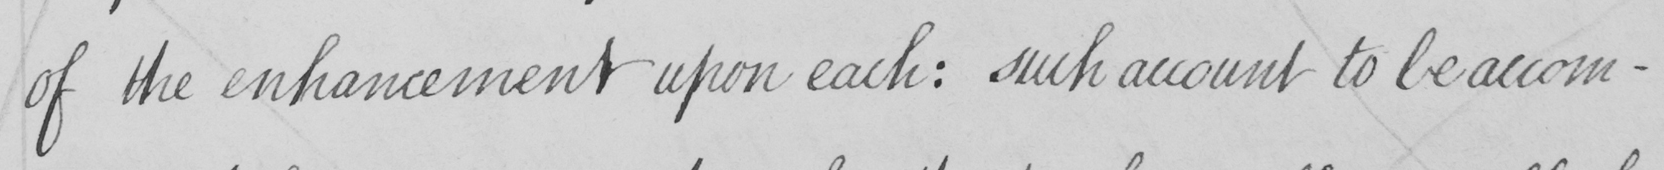Please transcribe the handwritten text in this image. of the enhancement upon each :  such account to be accom- 